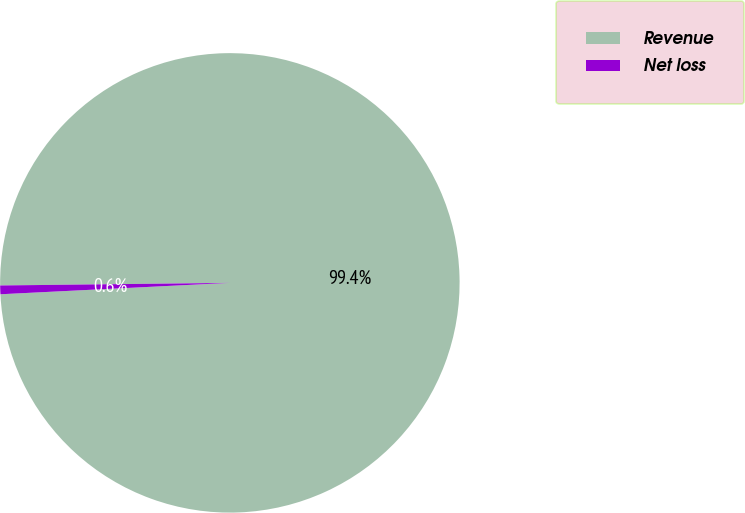Convert chart to OTSL. <chart><loc_0><loc_0><loc_500><loc_500><pie_chart><fcel>Revenue<fcel>Net loss<nl><fcel>99.39%<fcel>0.61%<nl></chart> 